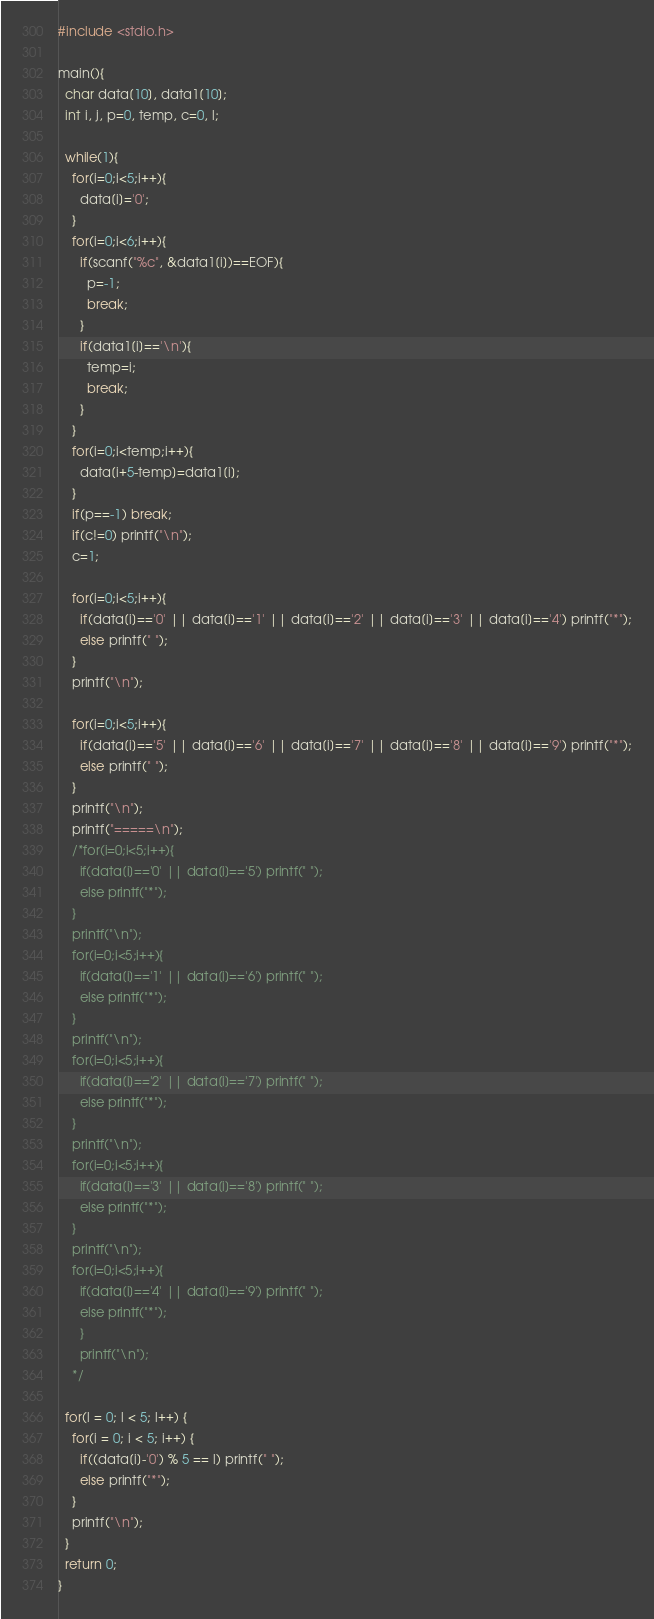<code> <loc_0><loc_0><loc_500><loc_500><_C_>#include <stdio.h>

main(){
  char data[10], data1[10];
  int i, j, p=0, temp, c=0, l;

  while(1){
    for(i=0;i<5;i++){
      data[i]='0';
    }
    for(i=0;i<6;i++){
      if(scanf("%c", &data1[i])==EOF){
        p=-1;
        break;
      }
      if(data1[i]=='\n'){
        temp=i;
        break;
      }
    }
    for(i=0;i<temp;i++){
      data[i+5-temp]=data1[i];
    }
    if(p==-1) break;
    if(c!=0) printf("\n");
    c=1;

    for(i=0;i<5;i++){
      if(data[i]=='0' || data[i]=='1' || data[i]=='2' || data[i]=='3' || data[i]=='4') printf("*");
      else printf(" ");
    }
    printf("\n");

    for(i=0;i<5;i++){
      if(data[i]=='5' || data[i]=='6' || data[i]=='7' || data[i]=='8' || data[i]=='9') printf("*");
      else printf(" ");
    }
    printf("\n");
    printf("=====\n");
    /*for(i=0;i<5;i++){
      if(data[i]=='0' || data[i]=='5') printf(" ");
      else printf("*");
    }
    printf("\n");
    for(i=0;i<5;i++){
      if(data[i]=='1' || data[i]=='6') printf(" ");
      else printf("*");
    }
    printf("\n");
    for(i=0;i<5;i++){
      if(data[i]=='2' || data[i]=='7') printf(" ");
      else printf("*");
    }
    printf("\n");
    for(i=0;i<5;i++){
      if(data[i]=='3' || data[i]=='8') printf(" ");
      else printf("*");
    }
    printf("\n");
    for(i=0;i<5;i++){
      if(data[i]=='4' || data[i]=='9') printf(" ");
      else printf("*");
      }
      printf("\n");
    */

  for(l = 0; l < 5; l++) {
    for(i = 0; i < 5; i++) {
      if((data[i]-'0') % 5 == l) printf(" ");
      else printf("*");
    }
    printf("\n");
  }
  return 0;
}</code> 